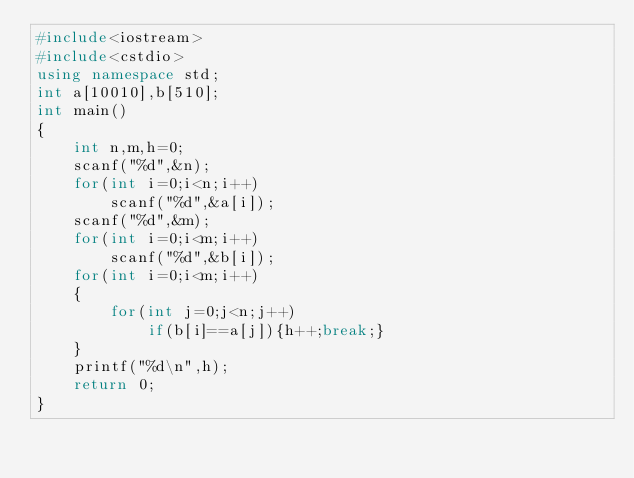<code> <loc_0><loc_0><loc_500><loc_500><_C++_>#include<iostream>
#include<cstdio>
using namespace std;
int a[10010],b[510];
int main()
{
    int n,m,h=0;
    scanf("%d",&n);
    for(int i=0;i<n;i++)
        scanf("%d",&a[i]);
    scanf("%d",&m);
    for(int i=0;i<m;i++)
        scanf("%d",&b[i]);
    for(int i=0;i<m;i++)
    {
        for(int j=0;j<n;j++)
            if(b[i]==a[j]){h++;break;}
    }
    printf("%d\n",h);
    return 0;
}</code> 